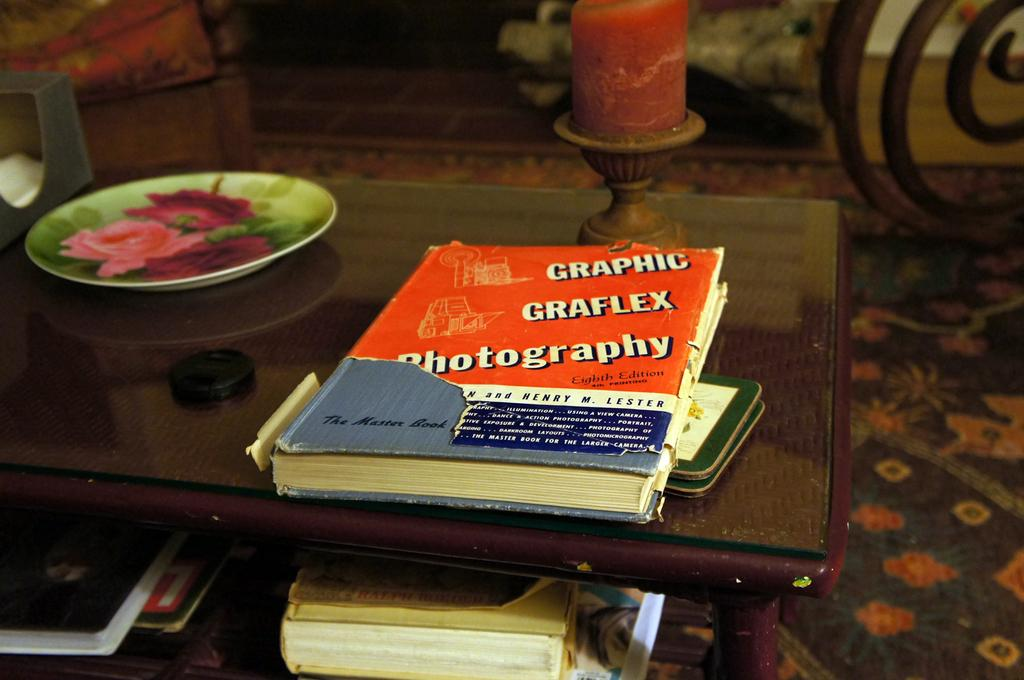<image>
Create a compact narrative representing the image presented. Red and blue book on a table that says "Graphic Graflex Photography". 